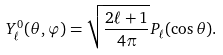Convert formula to latex. <formula><loc_0><loc_0><loc_500><loc_500>Y _ { \ell } ^ { 0 } ( \theta , \varphi ) = { \sqrt { \frac { 2 \ell + 1 } { 4 \pi } } } P _ { \ell } ( \cos \theta ) .</formula> 